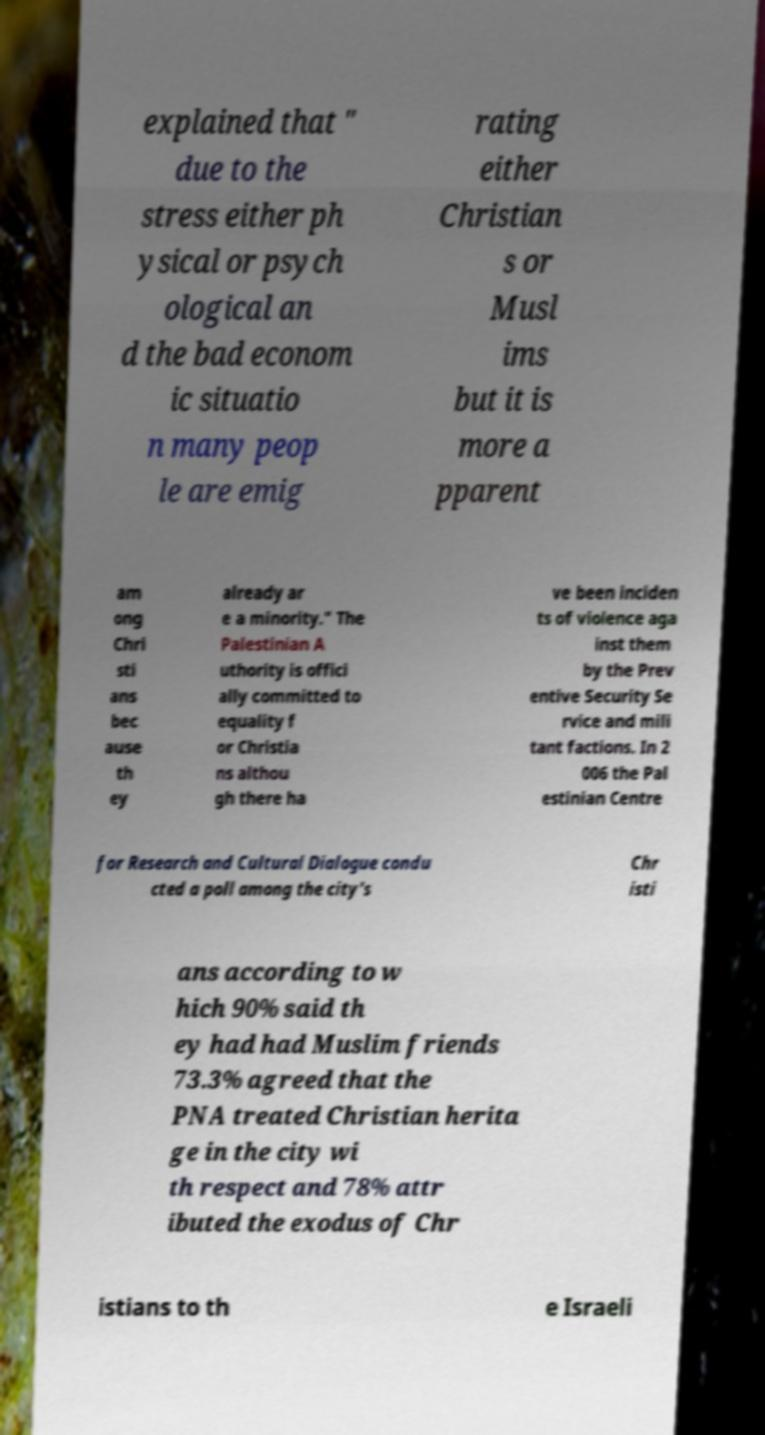Please identify and transcribe the text found in this image. explained that " due to the stress either ph ysical or psych ological an d the bad econom ic situatio n many peop le are emig rating either Christian s or Musl ims but it is more a pparent am ong Chri sti ans bec ause th ey already ar e a minority." The Palestinian A uthority is offici ally committed to equality f or Christia ns althou gh there ha ve been inciden ts of violence aga inst them by the Prev entive Security Se rvice and mili tant factions. In 2 006 the Pal estinian Centre for Research and Cultural Dialogue condu cted a poll among the city's Chr isti ans according to w hich 90% said th ey had had Muslim friends 73.3% agreed that the PNA treated Christian herita ge in the city wi th respect and 78% attr ibuted the exodus of Chr istians to th e Israeli 